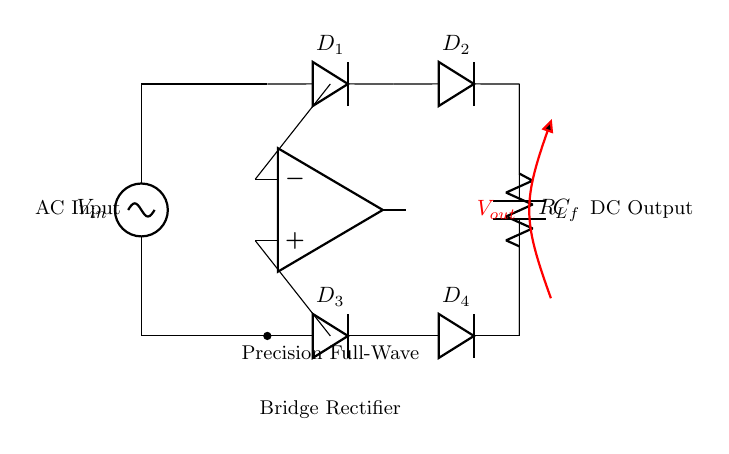What is the type of rectifier used in this circuit? The circuit is a full-wave bridge rectifier, indicated by the arrangement of the four diodes in a bridge configuration.
Answer: full-wave bridge rectifier How many diodes are present in the circuit? The diagram shows four diodes labeled D1, D2, D3, and D4, confirming there are four diodes in total.
Answer: four What is the function of the capacitor in this circuit? The capacitor, labeled C_f, is used for filtering the output voltage to smooth out the rectified signal, which reduces ripple.
Answer: filtering What is the role of the operational amplifier? The operational amplifier in the circuit serves to provide precision gain or buffering, enhancing the accuracy of the output signal derived from the rectified input.
Answer: precision gain What is connected to the output of this rectifier? The output is connected to both a capacitor and a load resistor, which combined serve to stabilize and utilize the rectified voltage in a circuit.
Answer: capacitor and load What type of output voltage does this circuit produce? The circuit provides a direct current (DC) output voltage, which is indicated by the labeling of V_out in red on the drawing.
Answer: direct current 